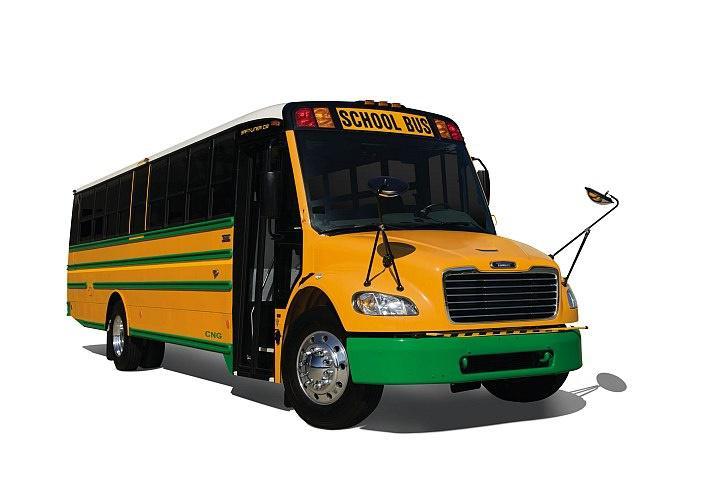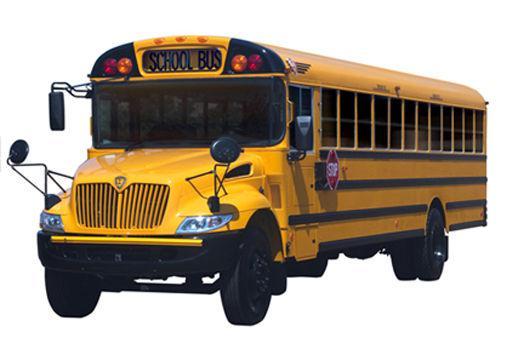The first image is the image on the left, the second image is the image on the right. Analyze the images presented: Is the assertion "Each image contains at least one flat-fronted yellow bus, and the bus in the right image is angled rightward." valid? Answer yes or no. No. 